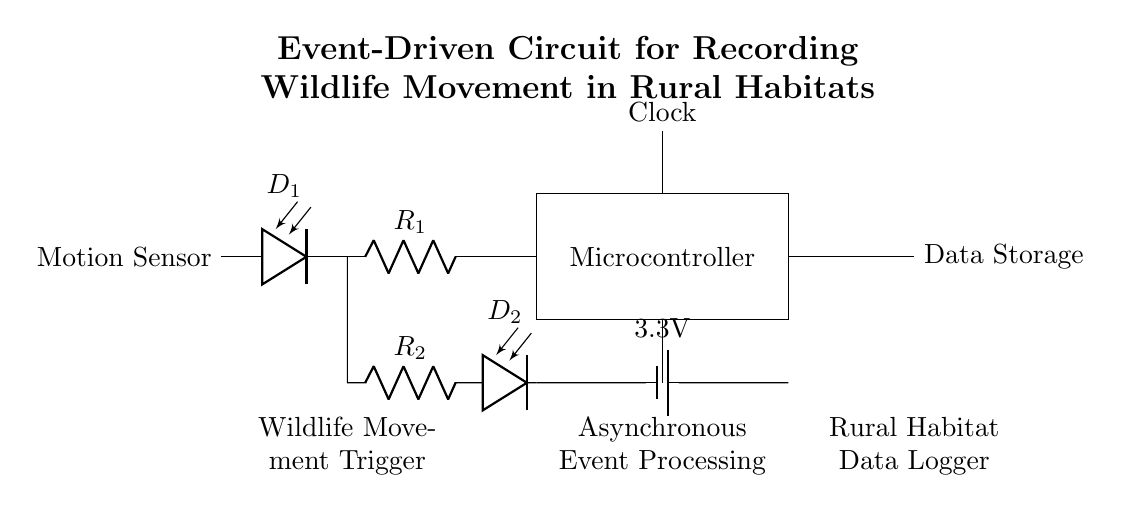What type of sensor is used in this circuit? The circuit diagram indicates a motion sensor is employed, labeled as "Motion Sensor," which is responsible for detecting the movement of wildlife.
Answer: motion sensor What is the voltage of the battery in the circuit? The battery is depicted with a label showing "3.3V," which means this is the voltage supplied by the battery to the circuit.
Answer: 3.3V How many resistors are present in the circuit? Upon examining the circuit diagram, there are two resistors labeled as R1 and R2. Therefore, the total count of resistors is two.
Answer: 2 What is the primary function of the microcontroller in this circuit? The microcontroller is positioned centrally in the circuit and is crucial for processing data received from the motion sensor, serving as the brain of the circuit to manage wildlife movement patterns.
Answer: data processing What does the circuit's asynchronous event processing signify? The term "Asynchronous Event Processing," noted in the diagram, implies that events (like wildlife motion) are handled in a non-blocking manner, allowing for efficient recording without needing a continuous active state.
Answer: non-blocking What component stores the data collected from wildlife movement? The data storage component is labeled as "Data Storage" in the circuit, indicating it is responsible for retaining the information gathered regarding wildlife and their movement patterns.
Answer: data storage 